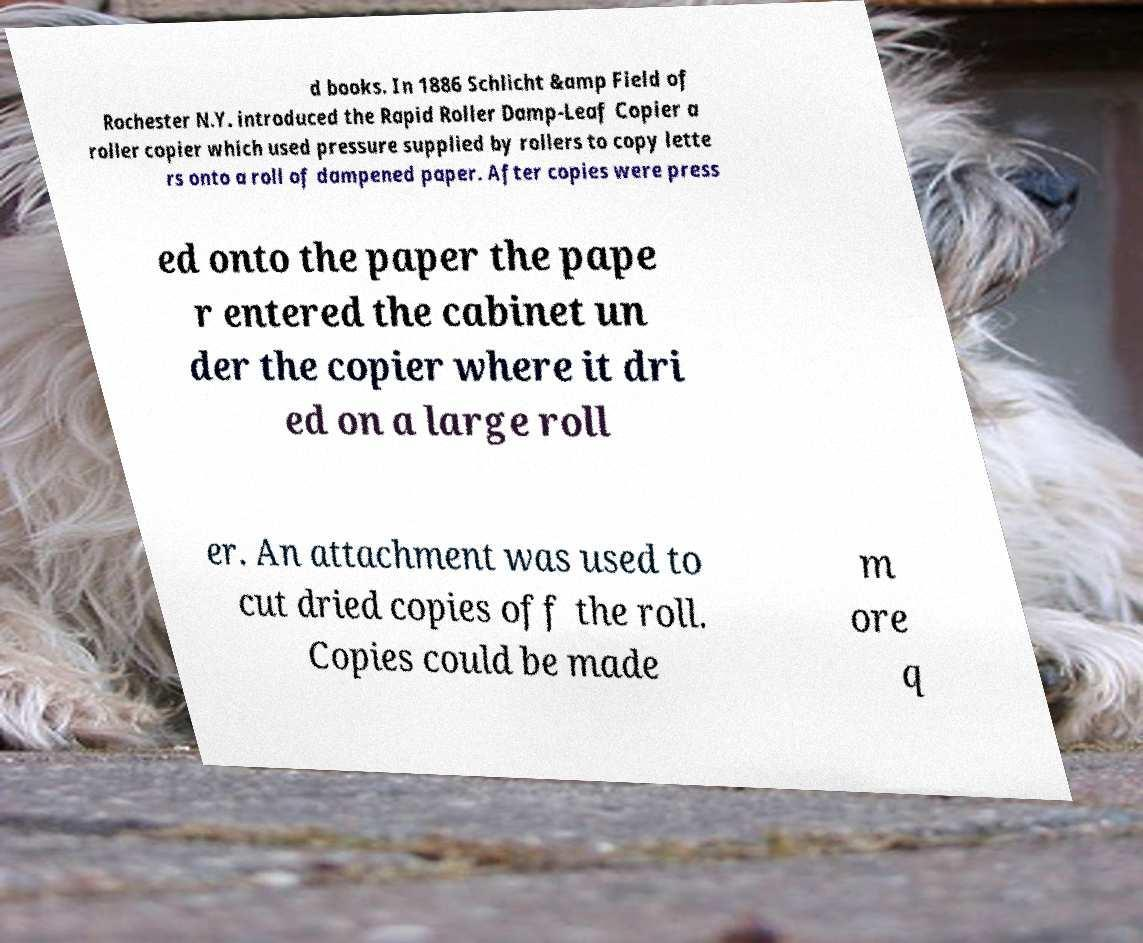Could you assist in decoding the text presented in this image and type it out clearly? d books. In 1886 Schlicht &amp Field of Rochester N.Y. introduced the Rapid Roller Damp-Leaf Copier a roller copier which used pressure supplied by rollers to copy lette rs onto a roll of dampened paper. After copies were press ed onto the paper the pape r entered the cabinet un der the copier where it dri ed on a large roll er. An attachment was used to cut dried copies off the roll. Copies could be made m ore q 